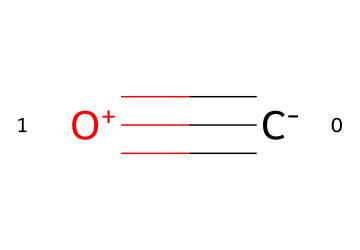What is the molecular formula of carbon monoxide? The molecule has one carbon atom and one oxygen atom, which gives the formula CO.
Answer: CO How many bonds are present in carbon monoxide? The SMILES notation indicates a triple bond between the carbon and oxygen atoms, which counts as three bonds.
Answer: 3 What type of hazard does carbon monoxide represent in poorly ventilated spaces? Carbon monoxide is a toxic gas and poses a serious health risk due to its potential to cause poisoning in enclosed areas.
Answer: toxic gas Which element carries a negative charge in carbon monoxide? The SMILES representation shows the carbon atom is denoted with a negative charge, indicating that it carries the negative charge.
Answer: carbon How does the molecular arrangement of carbon monoxide contribute to its toxicity? The triple bond creates a stable yet reactive molecule that can easily bind with hemoglobin, reducing oxygen transport in the bloodstream, leading to toxicity.
Answer: it binds with hemoglobin What is the hybridization state of the carbon atom in carbon monoxide? The carbon atom is involved in a triple bond, indicating that it is sp hybridized due to its linear geometry and bonding characteristics.
Answer: sp How does carbon monoxide's molecular structure affect its solubility in water? The linear structure and lack of polar functional groups limits its interaction with water molecules, resulting in low solubility.
Answer: low solubility 